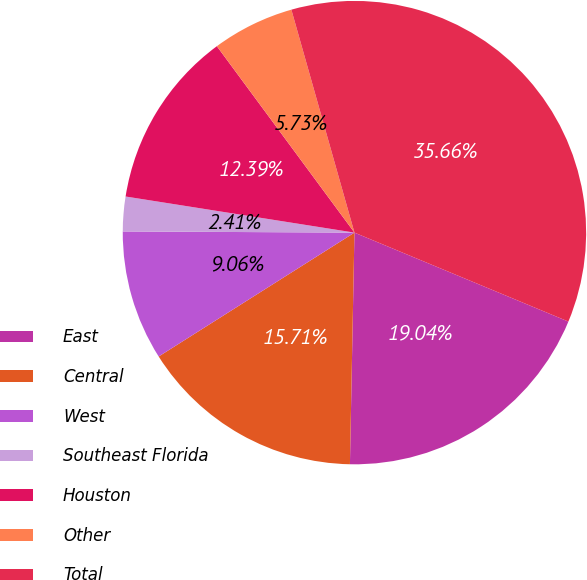Convert chart. <chart><loc_0><loc_0><loc_500><loc_500><pie_chart><fcel>East<fcel>Central<fcel>West<fcel>Southeast Florida<fcel>Houston<fcel>Other<fcel>Total<nl><fcel>19.04%<fcel>15.71%<fcel>9.06%<fcel>2.41%<fcel>12.39%<fcel>5.73%<fcel>35.66%<nl></chart> 